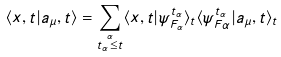Convert formula to latex. <formula><loc_0><loc_0><loc_500><loc_500>\langle x , t | a _ { \mu } , t \rangle = \sum _ { \stackrel { \alpha } { t _ { \alpha } \leq t } } \langle x , t | \psi ^ { t _ { \alpha } } _ { F _ { \alpha } } \rangle _ { t } \langle \psi ^ { t _ { \alpha } } _ { F \alpha } | a _ { \mu } , t \rangle _ { t }</formula> 